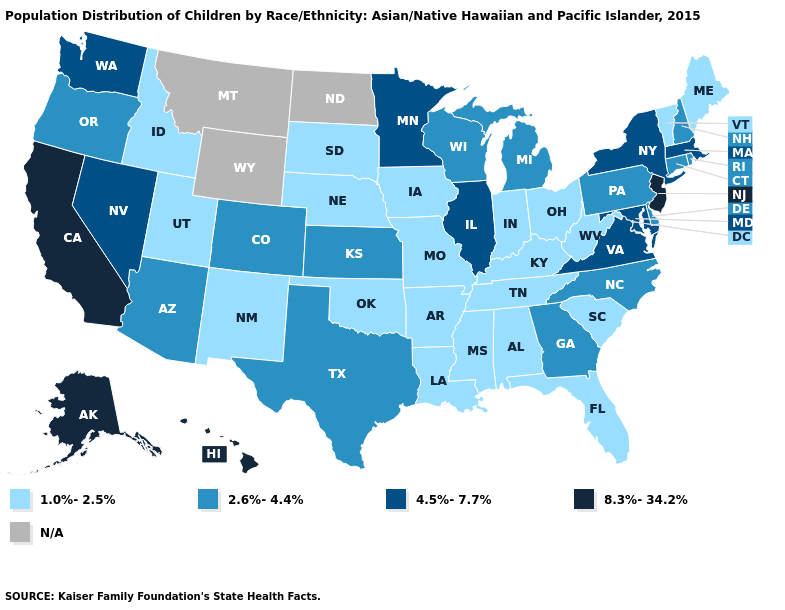Name the states that have a value in the range 8.3%-34.2%?
Short answer required. Alaska, California, Hawaii, New Jersey. Which states have the lowest value in the USA?
Write a very short answer. Alabama, Arkansas, Florida, Idaho, Indiana, Iowa, Kentucky, Louisiana, Maine, Mississippi, Missouri, Nebraska, New Mexico, Ohio, Oklahoma, South Carolina, South Dakota, Tennessee, Utah, Vermont, West Virginia. Among the states that border Washington , does Idaho have the highest value?
Be succinct. No. Name the states that have a value in the range 4.5%-7.7%?
Quick response, please. Illinois, Maryland, Massachusetts, Minnesota, Nevada, New York, Virginia, Washington. Which states have the lowest value in the Northeast?
Quick response, please. Maine, Vermont. What is the highest value in states that border Oklahoma?
Be succinct. 2.6%-4.4%. Which states hav the highest value in the Northeast?
Answer briefly. New Jersey. What is the value of Colorado?
Short answer required. 2.6%-4.4%. Name the states that have a value in the range 2.6%-4.4%?
Answer briefly. Arizona, Colorado, Connecticut, Delaware, Georgia, Kansas, Michigan, New Hampshire, North Carolina, Oregon, Pennsylvania, Rhode Island, Texas, Wisconsin. What is the highest value in states that border Iowa?
Concise answer only. 4.5%-7.7%. Is the legend a continuous bar?
Concise answer only. No. What is the value of Michigan?
Answer briefly. 2.6%-4.4%. What is the value of Illinois?
Give a very brief answer. 4.5%-7.7%. Among the states that border Wyoming , which have the lowest value?
Concise answer only. Idaho, Nebraska, South Dakota, Utah. 